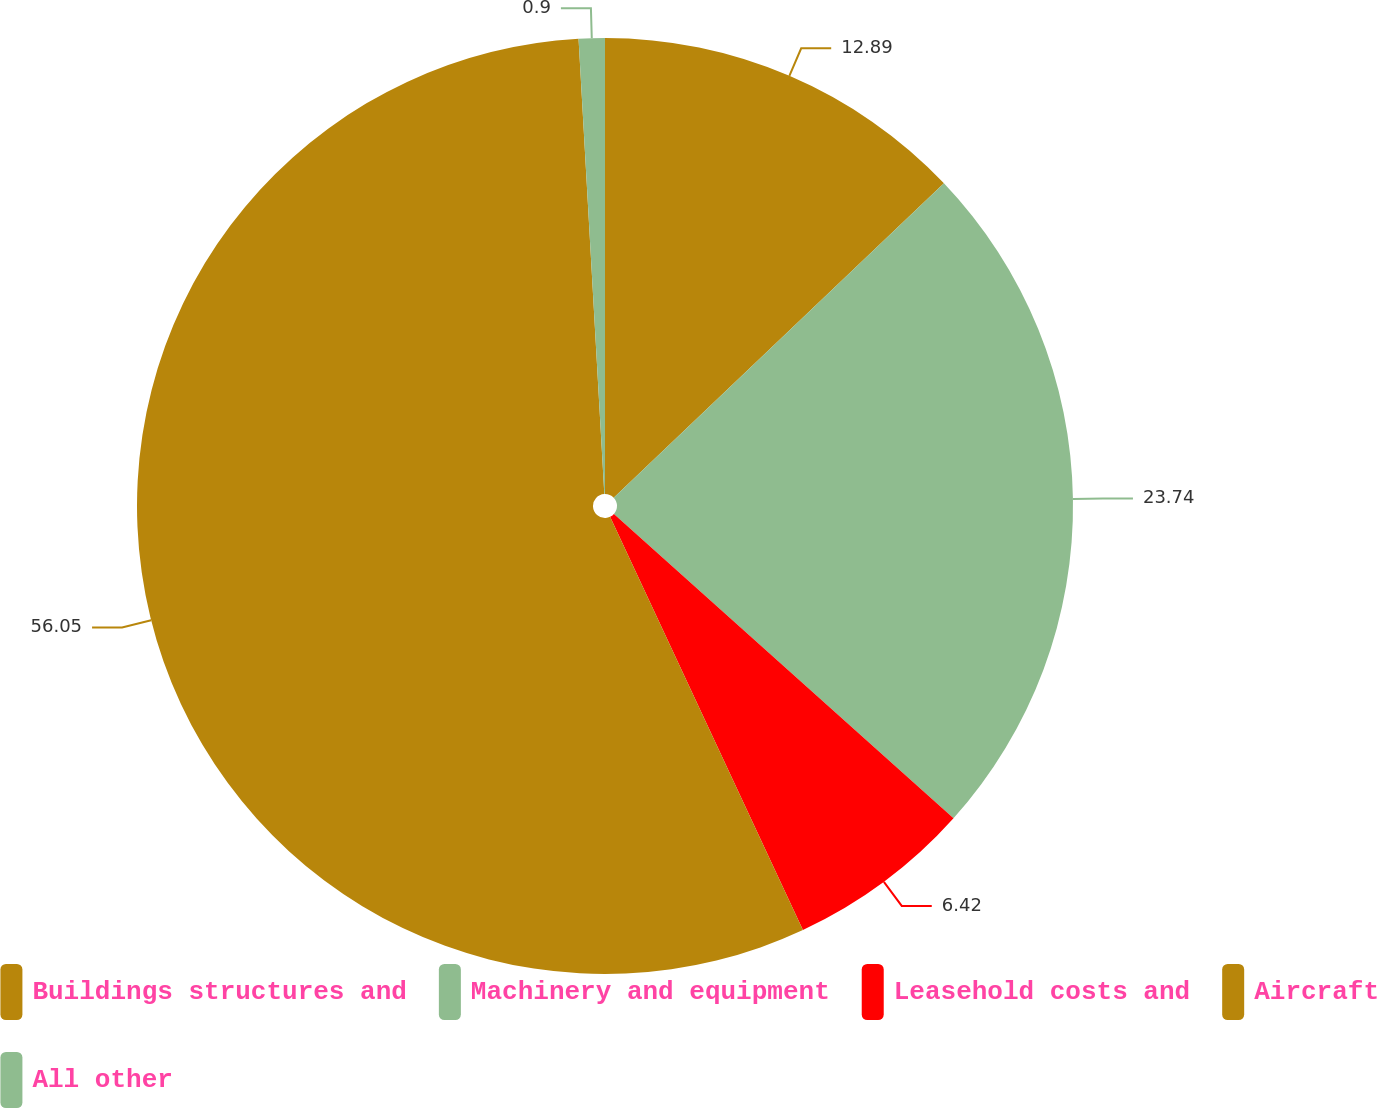<chart> <loc_0><loc_0><loc_500><loc_500><pie_chart><fcel>Buildings structures and<fcel>Machinery and equipment<fcel>Leasehold costs and<fcel>Aircraft<fcel>All other<nl><fcel>12.89%<fcel>23.74%<fcel>6.42%<fcel>56.05%<fcel>0.9%<nl></chart> 